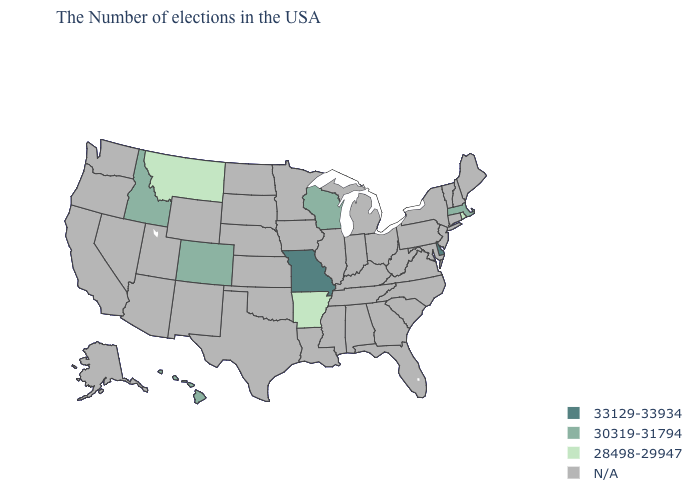What is the value of Texas?
Keep it brief. N/A. What is the lowest value in the USA?
Concise answer only. 28498-29947. What is the value of Wyoming?
Keep it brief. N/A. Does the map have missing data?
Keep it brief. Yes. What is the lowest value in the USA?
Write a very short answer. 28498-29947. What is the highest value in the MidWest ?
Quick response, please. 33129-33934. What is the value of South Carolina?
Quick response, please. N/A. What is the value of Alaska?
Write a very short answer. N/A. What is the value of North Dakota?
Short answer required. N/A. What is the highest value in the South ?
Be succinct. 33129-33934. Which states have the lowest value in the USA?
Concise answer only. Rhode Island, Arkansas, Montana. Does Delaware have the highest value in the South?
Answer briefly. Yes. 